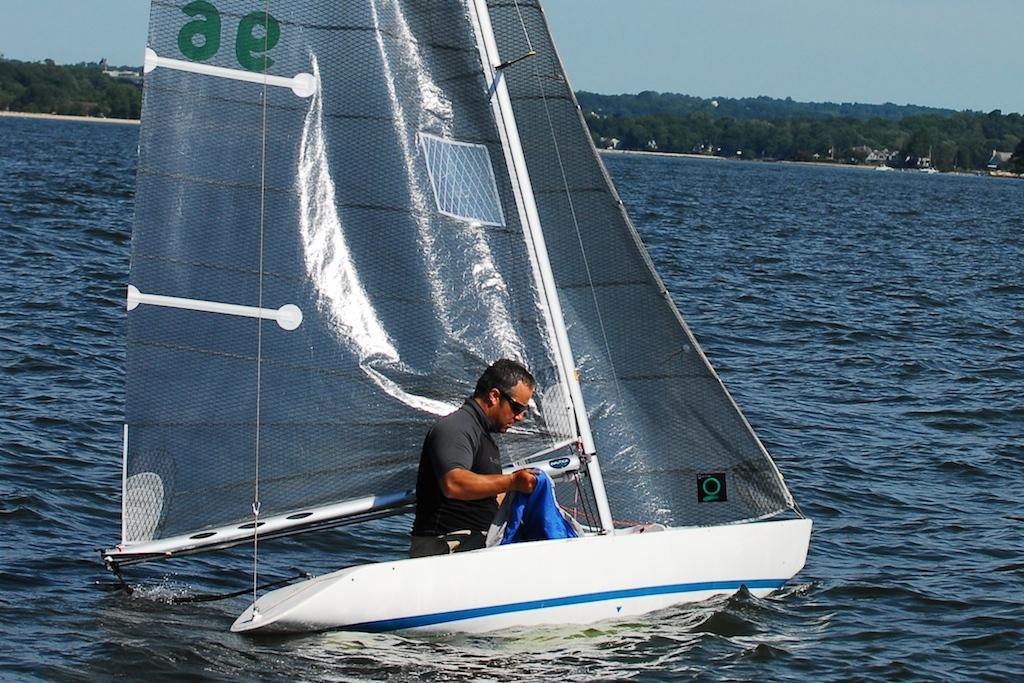Please provide a concise description of this image. In this picture I can see at the bottom there is a man in the boat and there is water, in the background there are trees. At the top there is the sky. 